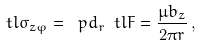Convert formula to latex. <formula><loc_0><loc_0><loc_500><loc_500>\ t l \sigma _ { z \varphi } = \ p d _ { r } \ t l F = \frac { \mu b _ { z } } { 2 \pi r } \, ,</formula> 